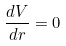Convert formula to latex. <formula><loc_0><loc_0><loc_500><loc_500>\frac { d V } { d r } = 0</formula> 